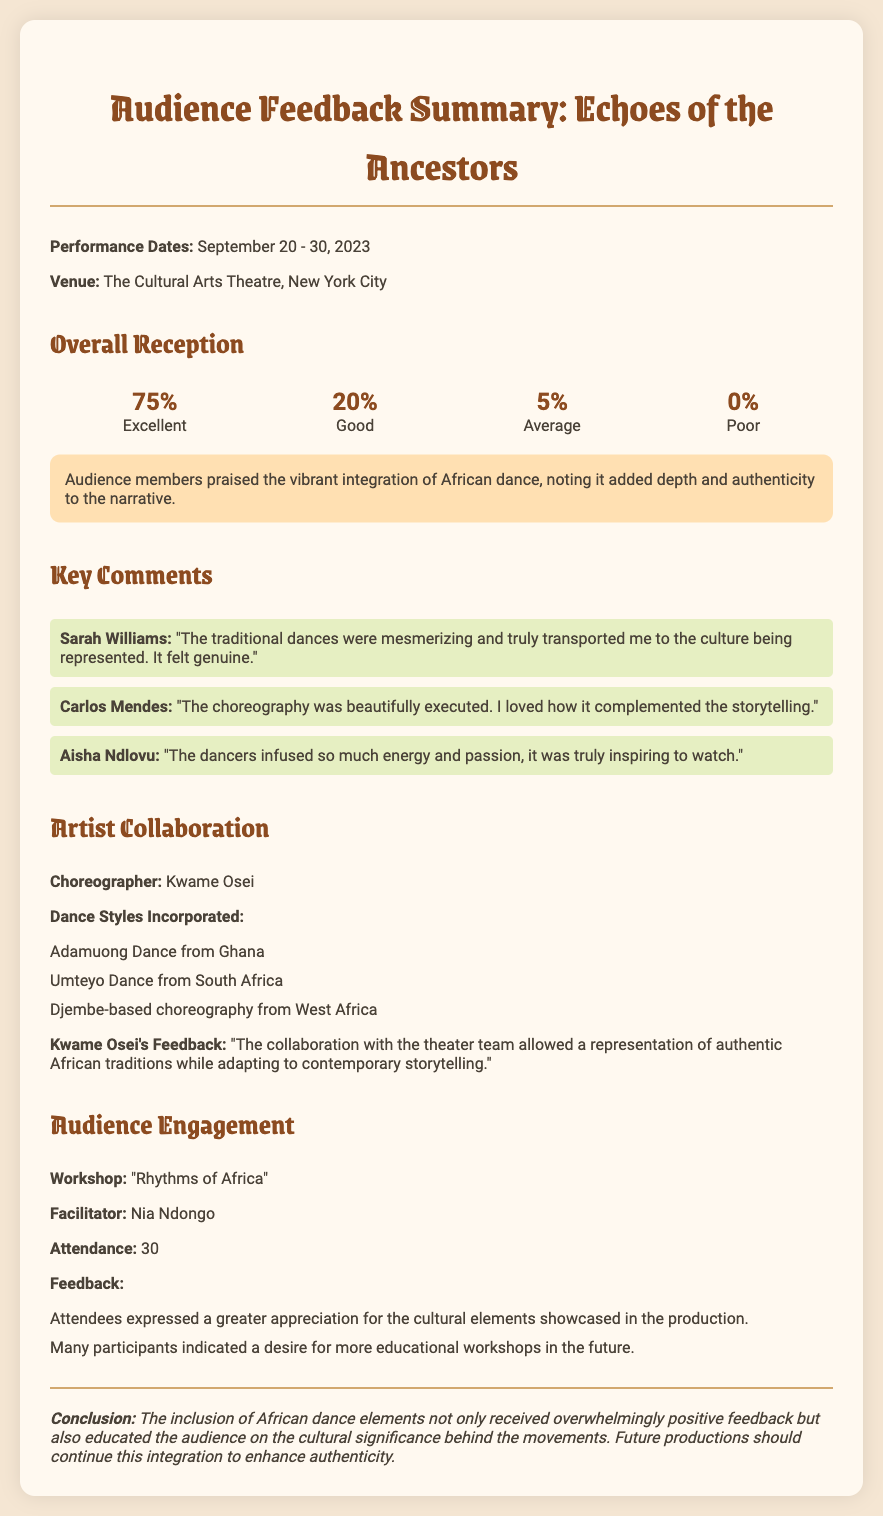what were the performance dates? The performance dates are explicitly mentioned in the document, detailing the start and end of the production.
Answer: September 20 - 30, 2023 who was the choreographer? The choreographer for the production is specifically listed in the document.
Answer: Kwame Osei what percentage of the audience rated the performance as excellent? The document includes specific ratings given by the audience, indicating the percentage for each category.
Answer: 75% which dance style from Ghana was incorporated? The document lists the different dance styles integrated into the performance, including one from Ghana.
Answer: Adamuong Dance what was the title of the workshop facilitated? The title of the workshop is mentioned in the audience engagement section of the document.
Answer: Rhythms of Africa how many attendees were at the workshop? The number of attendees at the workshop is specified in the document.
Answer: 30 what type of feedback did attendees provide regarding the cultural elements? Feedback summarizing attendee responses about the production's cultural elements is included.
Answer: Greater appreciation what is the conclusion regarding African dance elements in the production? The conclusion summarizing the impact of African dance elements is clearly stated in the conclusion section.
Answer: Enhance authenticity 